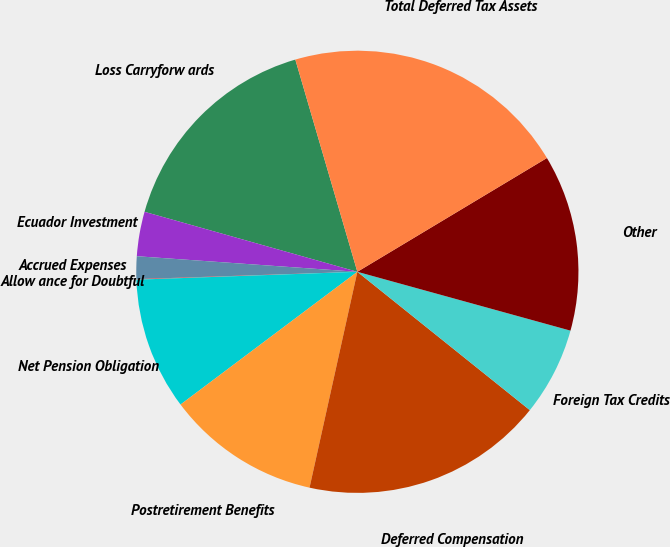Convert chart to OTSL. <chart><loc_0><loc_0><loc_500><loc_500><pie_chart><fcel>Loss Carryforw ards<fcel>Ecuador Investment<fcel>Accrued Expenses<fcel>Allow ance for Doubtful<fcel>Net Pension Obligation<fcel>Postretirement Benefits<fcel>Deferred Compensation<fcel>Foreign Tax Credits<fcel>Other<fcel>Total Deferred Tax Assets<nl><fcel>16.1%<fcel>3.25%<fcel>1.65%<fcel>0.04%<fcel>9.68%<fcel>11.28%<fcel>17.71%<fcel>6.47%<fcel>12.89%<fcel>20.92%<nl></chart> 